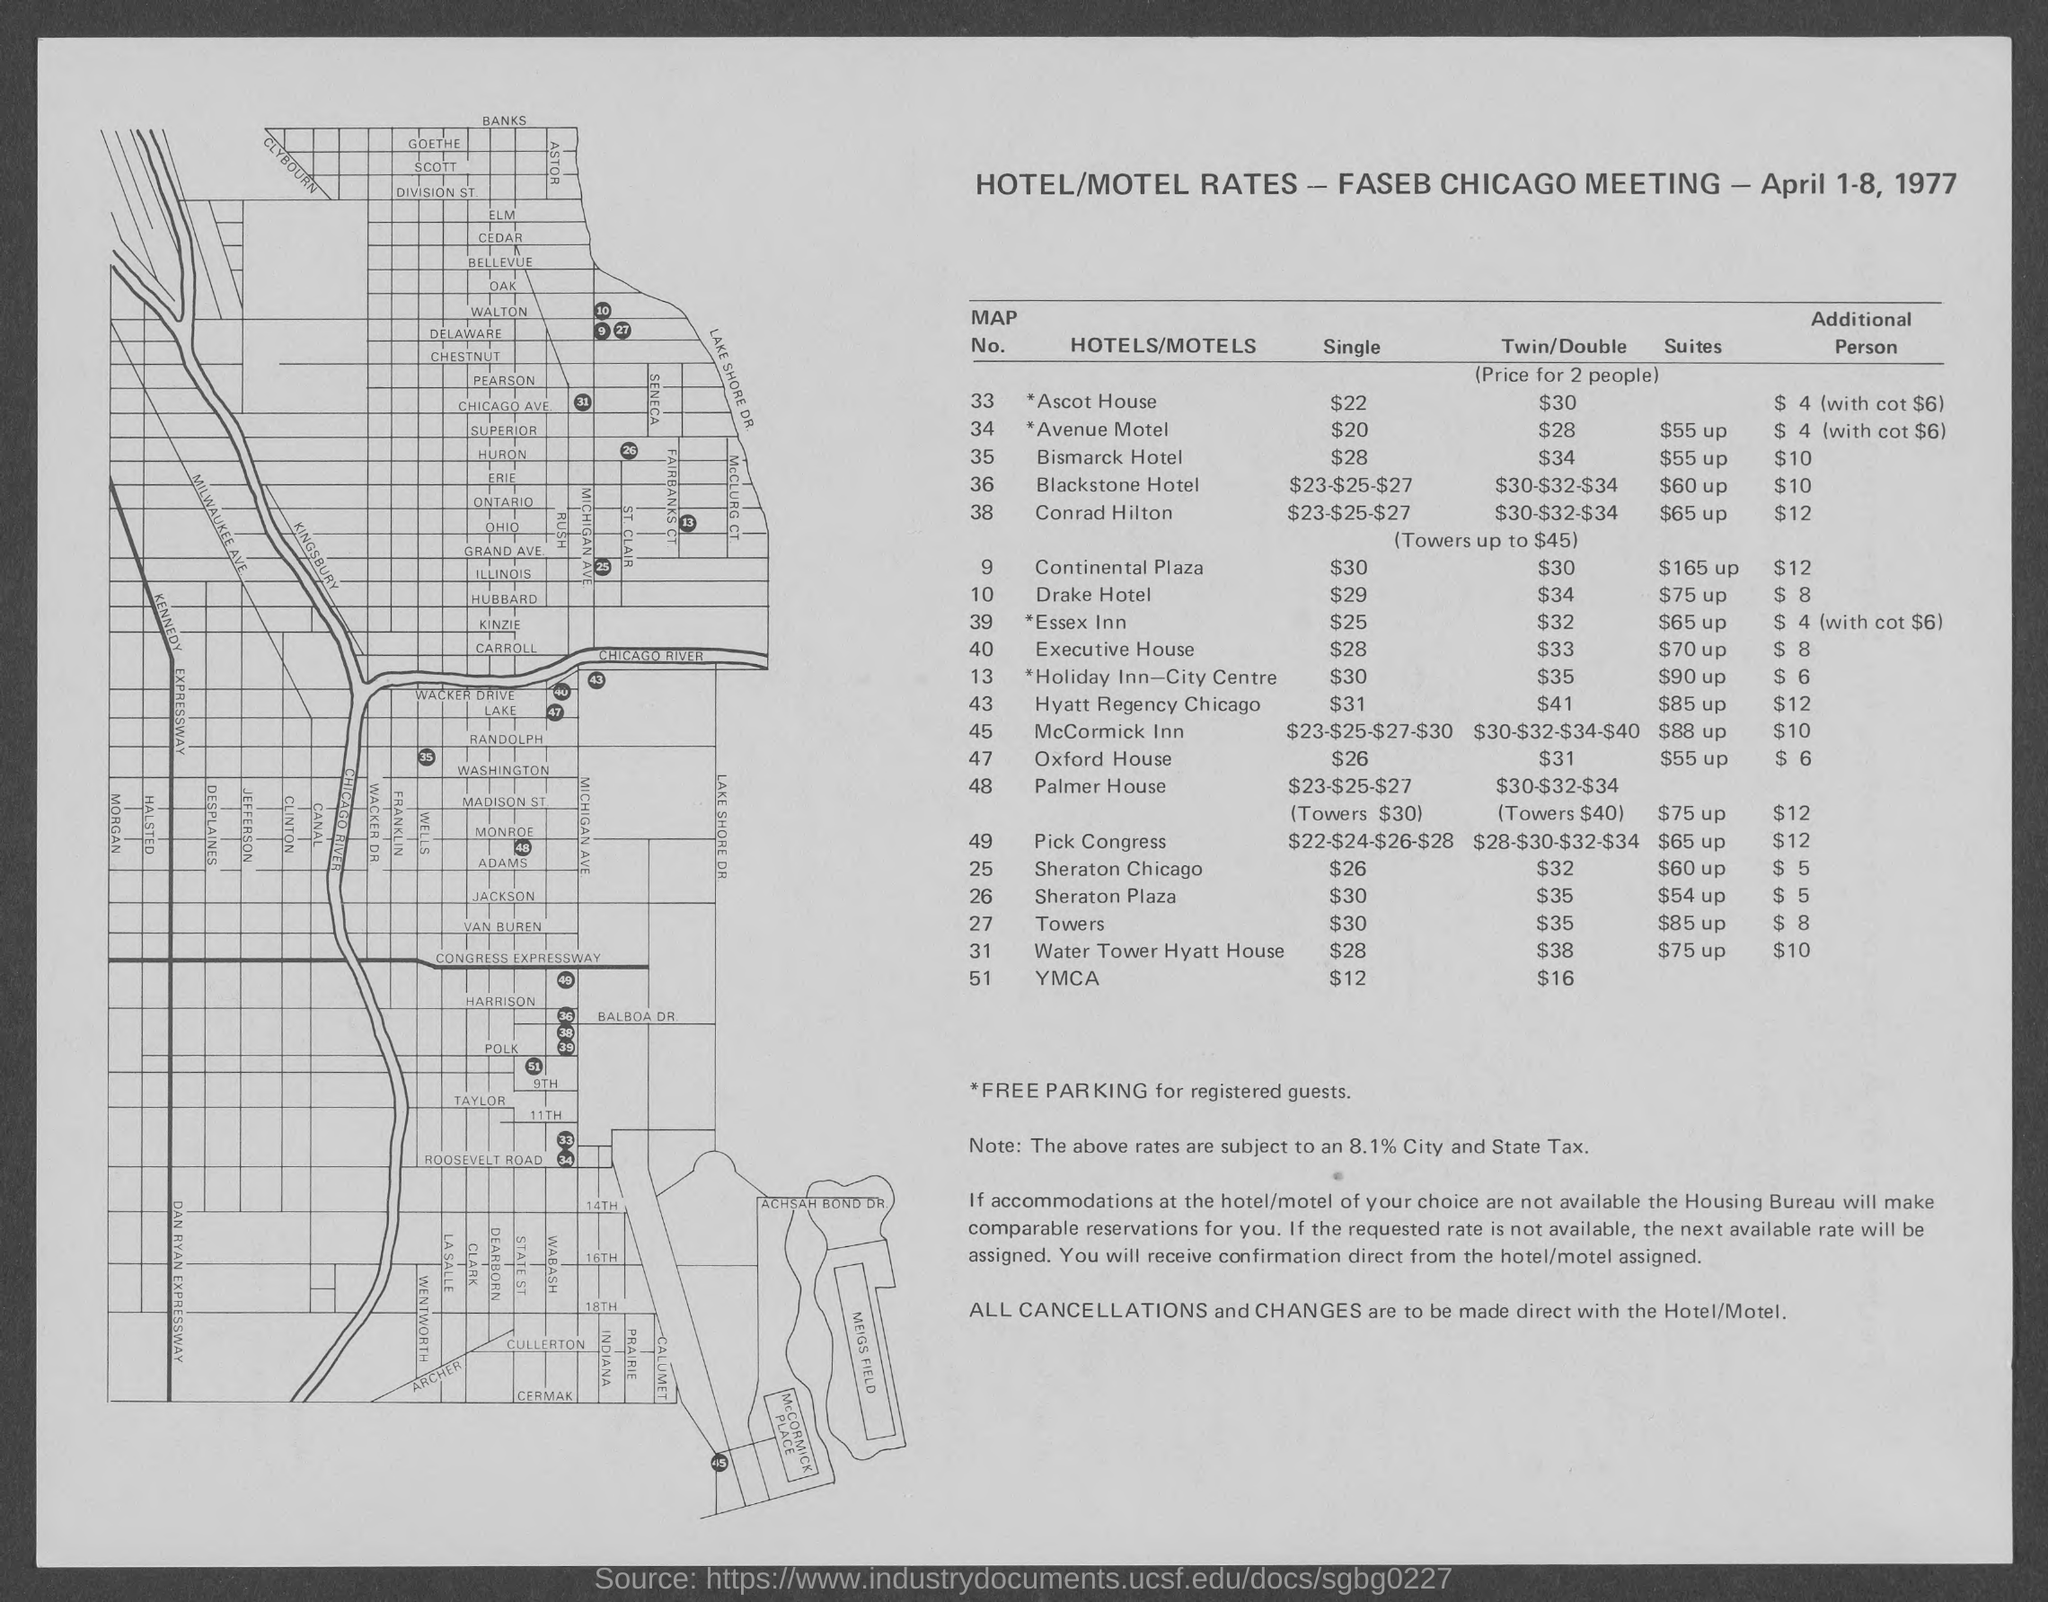Identify some key points in this picture. The number for the Bismarck Hotel is 35. The map number for Ascot House is 33. The map number for the Drake Hotel is 10. The map number for *Avenue Motel is 34. The map number for Conrad Hilton is 38. 